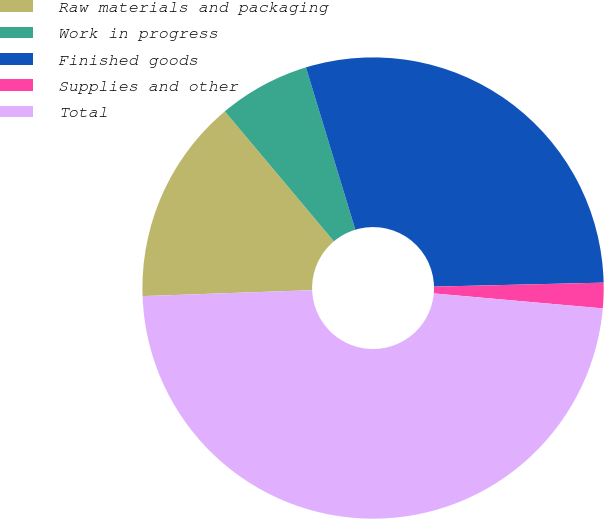Convert chart. <chart><loc_0><loc_0><loc_500><loc_500><pie_chart><fcel>Raw materials and packaging<fcel>Work in progress<fcel>Finished goods<fcel>Supplies and other<fcel>Total<nl><fcel>14.45%<fcel>6.41%<fcel>29.33%<fcel>1.78%<fcel>48.04%<nl></chart> 